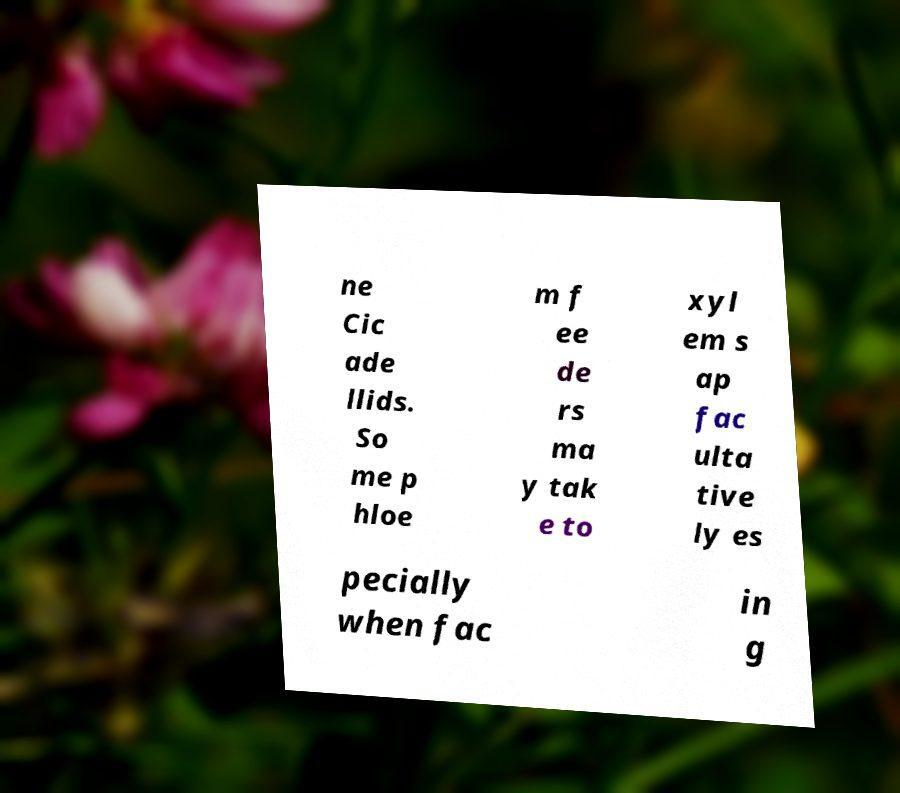Can you read and provide the text displayed in the image?This photo seems to have some interesting text. Can you extract and type it out for me? ne Cic ade llids. So me p hloe m f ee de rs ma y tak e to xyl em s ap fac ulta tive ly es pecially when fac in g 